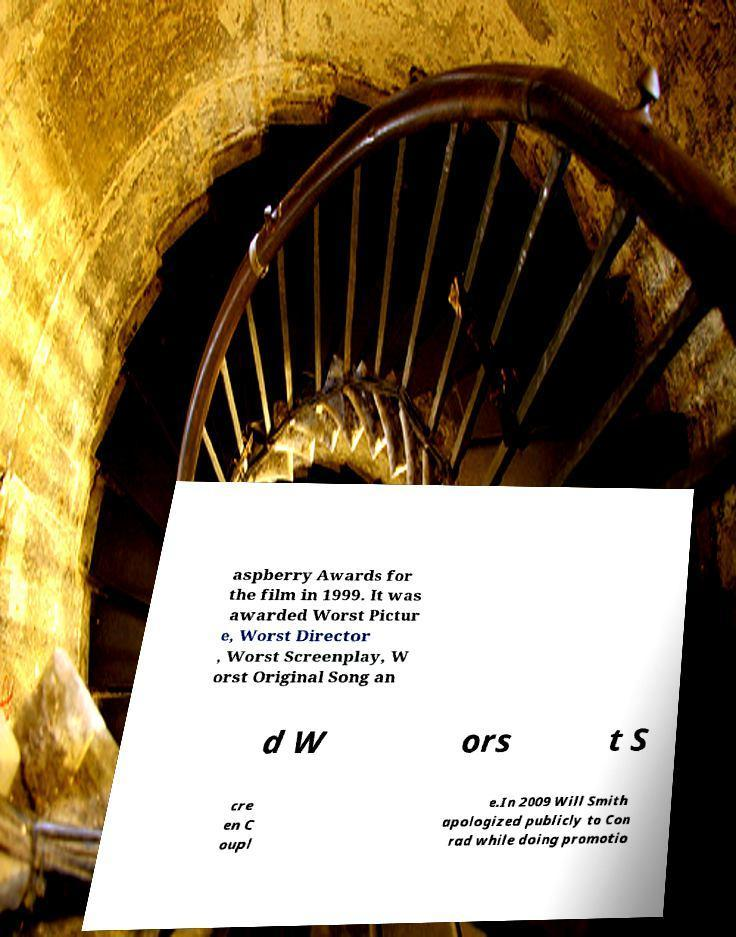Could you extract and type out the text from this image? aspberry Awards for the film in 1999. It was awarded Worst Pictur e, Worst Director , Worst Screenplay, W orst Original Song an d W ors t S cre en C oupl e.In 2009 Will Smith apologized publicly to Con rad while doing promotio 